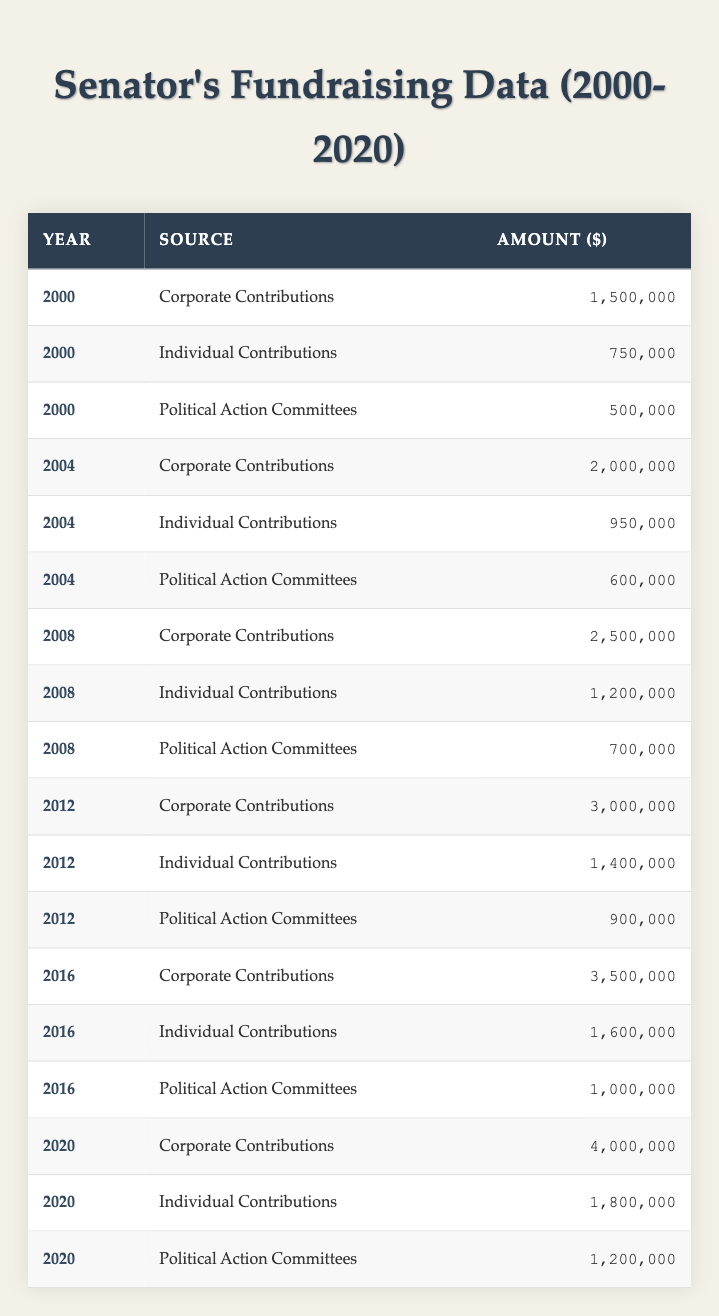What was the total fundraising amount from Corporate Contributions in 2020? From the table, in 2020, the Corporate Contributions amount is listed as 4,000,000. This is the only entry for Corporate Contributions in that year, so no additional calculations are needed.
Answer: 4,000,000 What year had the highest total amount of Individual Contributions? By examining the Individual Contributions per year: 2000 (750,000), 2004 (950,000), 2008 (1,200,000), 2012 (1,400,000), 2016 (1,600,000), and 2020 (1,800,000). The highest is in 2020 with 1,800,000.
Answer: 2020 What is the average amount raised from Political Action Committees over the years? The amounts raised from Political Action Committees are: 500,000 (2000), 600,000 (2004), 700,000 (2008), 900,000 (2012), 1,000,000 (2016), and 1,200,000 (2020). There are 6 data points: (500,000 + 600,000 + 700,000 + 900,000 + 1,000,000 + 1,200,000) = 4,900,000. The average is 4,900,000 / 6 ≈ 816,667.
Answer: 816,667 Which fundraising source had the largest total amount raised over all years specified? Summing the total amounts by source: Corporate Contributions (1,500,000 + 2,000,000 + 2,500,000 + 3,000,000 + 3,500,000 + 4,000,000 = 16,500,000), Individual Contributions (750,000 + 950,000 + 1,200,000 + 1,400,000 + 1,600,000 + 1,800,000 = 7,700,000), Political Action Committees (500,000 + 600,000 + 700,000 + 900,000 + 1,000,000 + 1,200,000 = 4,900,000). Corporate Contributions total 16,500,000, which is the largest.
Answer: Corporate Contributions Was there an increase in Individual Contributions from 2012 to 2016? Individual Contributions in 2012 is 1,400,000 and in 2016 is 1,600,000. Since 1,600,000 > 1,400,000, this indicates an increase during that period.
Answer: Yes What was the total fundraising amount for each year, and which year had the lowest total? Totals per year: 2000: 2,250,000 (1,500,000 + 750,000 + 500,000), 2004: 2,550,000 (2,000,000 + 950,000 + 600,000), 2008: 4,400,000 (2,500,000 + 1,200,000 + 700,000), 2012: 5,300,000 (3,000,000 + 1,400,000 + 900,000), 2016: 5,600,000 (3,500,000 + 1,600,000 + 1,000,000), 2020: 6,200,000 (4,000,000 + 1,800,000 + 1,200,000). The lowest total is from 2000.
Answer: 2000 What percentage of the total fundraising in 2020 came from Individual Contributions? The total in 2020 is (4,000,000 + 1,800,000 + 1,200,000) = 7,000,000. Individual Contributions were 1,800,000, so the percentage is (1,800,000 / 7,000,000) * 100 ≈ 25.71%.
Answer: 25.71% Which source saw the most significant increase in funding from 2000 to 2020? Compare the amounts: Corporate Contributions increased from 1,500,000 (2000) to 4,000,000 (2020) for a difference of 2,500,000. Individual Contributions increased from 750,000 to 1,800,000 for a difference of 1,050,000. Political Action Committees increased from 500,000 to 1,200,000 for a difference of 700,000. The largest increase was in Corporate Contributions.
Answer: Corporate Contributions How much more did the senator raise in 2016 compared to 2012? The total for 2016 is (3,500,000 + 1,600,000 + 1,000,000) = 6,100,000 and for 2012: (3,000,000 + 1,400,000 + 900,000) = 5,300,000. The difference is 6,100,000 - 5,300,000 = 800,000.
Answer: 800,000 